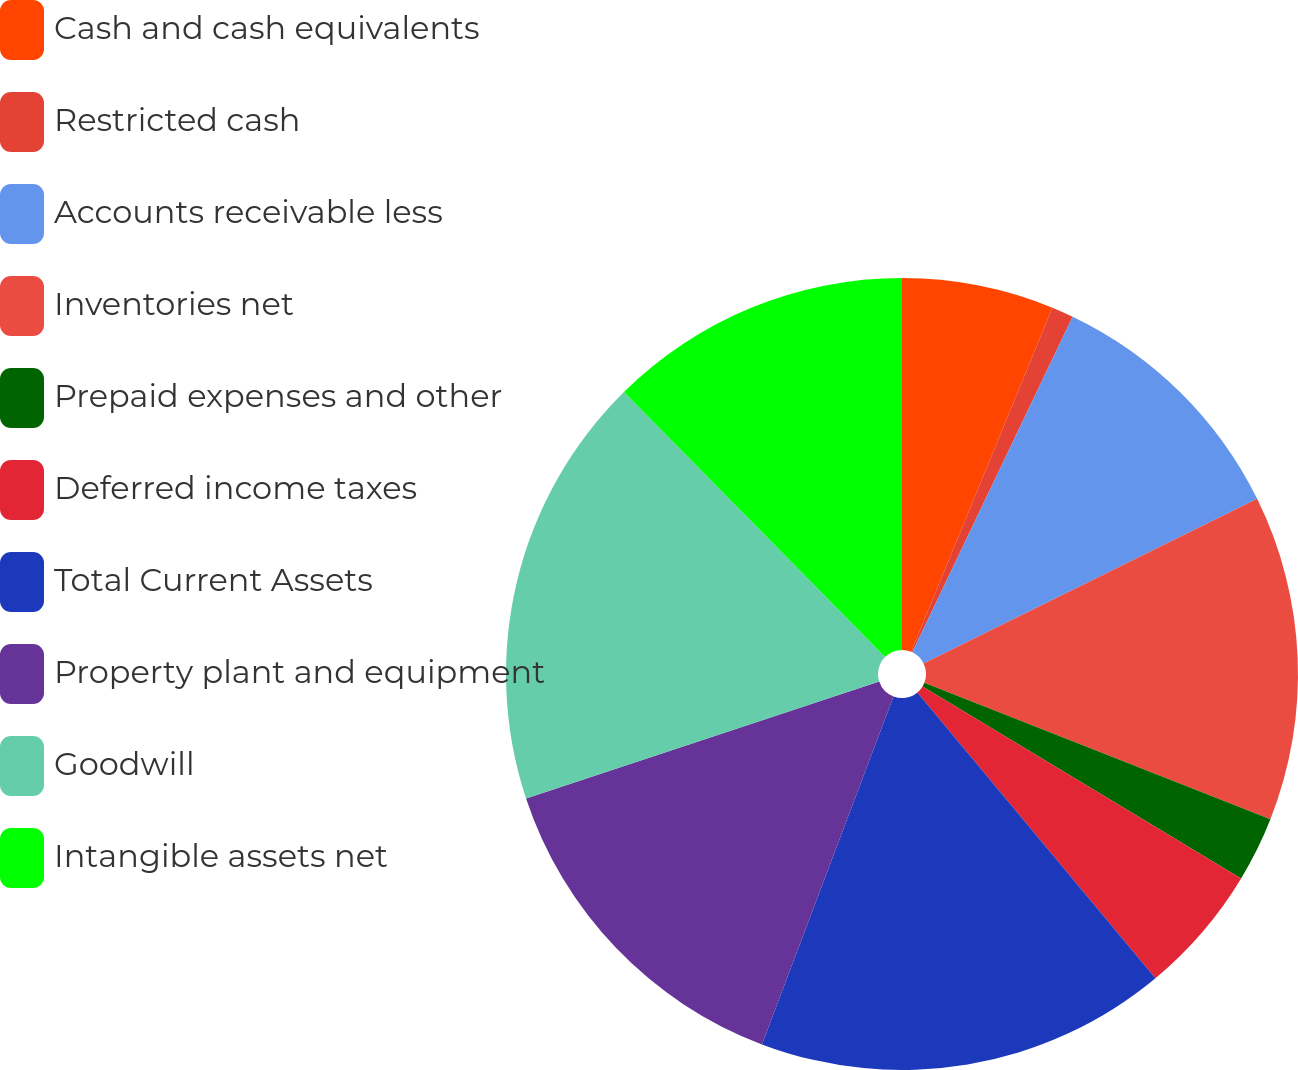Convert chart. <chart><loc_0><loc_0><loc_500><loc_500><pie_chart><fcel>Cash and cash equivalents<fcel>Restricted cash<fcel>Accounts receivable less<fcel>Inventories net<fcel>Prepaid expenses and other<fcel>Deferred income taxes<fcel>Total Current Assets<fcel>Property plant and equipment<fcel>Goodwill<fcel>Intangible assets net<nl><fcel>6.2%<fcel>0.89%<fcel>10.62%<fcel>13.27%<fcel>2.66%<fcel>5.31%<fcel>16.81%<fcel>14.16%<fcel>17.7%<fcel>12.39%<nl></chart> 